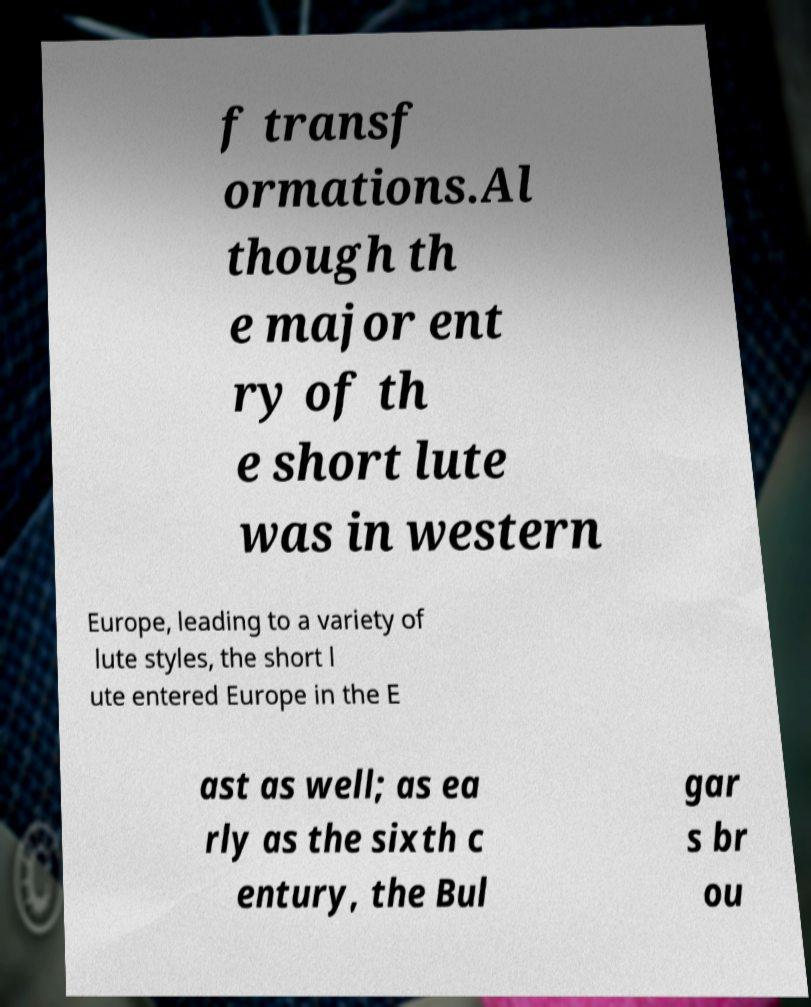Can you accurately transcribe the text from the provided image for me? f transf ormations.Al though th e major ent ry of th e short lute was in western Europe, leading to a variety of lute styles, the short l ute entered Europe in the E ast as well; as ea rly as the sixth c entury, the Bul gar s br ou 